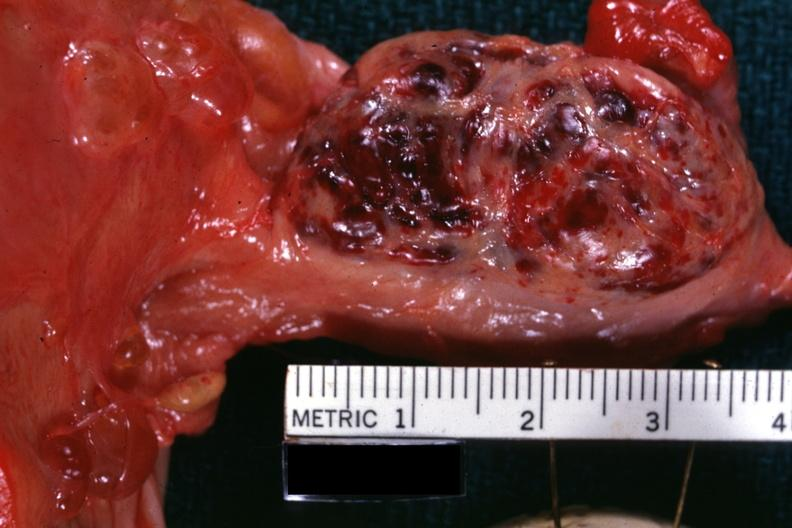does this image show close-up external view of hemorrhagic mass?
Answer the question using a single word or phrase. Yes 